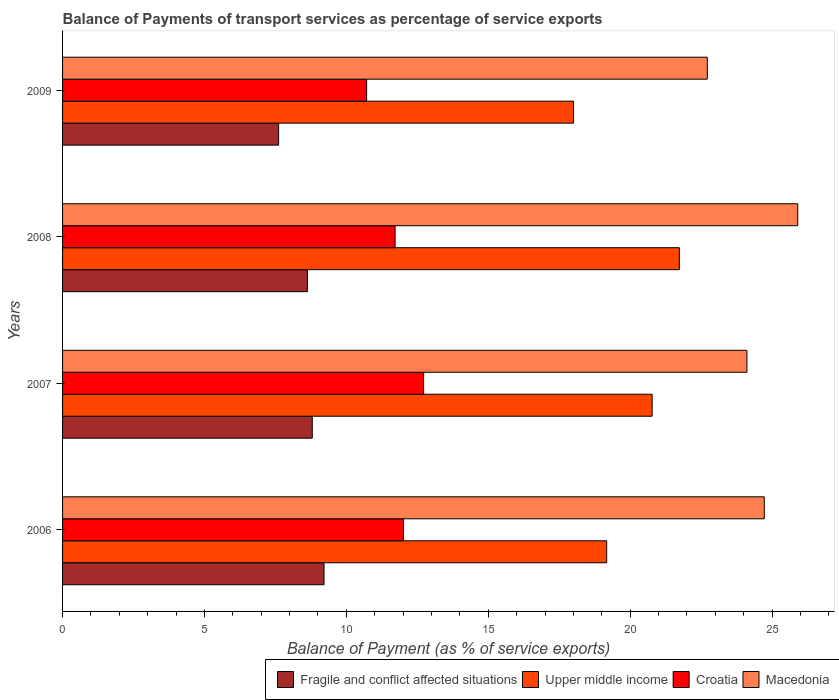How many different coloured bars are there?
Keep it short and to the point. 4. How many groups of bars are there?
Your answer should be very brief. 4. Are the number of bars per tick equal to the number of legend labels?
Make the answer very short. Yes. Are the number of bars on each tick of the Y-axis equal?
Your response must be concise. Yes. What is the label of the 1st group of bars from the top?
Give a very brief answer. 2009. In how many cases, is the number of bars for a given year not equal to the number of legend labels?
Make the answer very short. 0. What is the balance of payments of transport services in Croatia in 2009?
Provide a succinct answer. 10.71. Across all years, what is the maximum balance of payments of transport services in Upper middle income?
Your answer should be very brief. 21.73. Across all years, what is the minimum balance of payments of transport services in Croatia?
Your answer should be compact. 10.71. What is the total balance of payments of transport services in Upper middle income in the graph?
Keep it short and to the point. 79.69. What is the difference between the balance of payments of transport services in Upper middle income in 2007 and that in 2009?
Your answer should be compact. 2.77. What is the difference between the balance of payments of transport services in Macedonia in 2009 and the balance of payments of transport services in Croatia in 2007?
Give a very brief answer. 10. What is the average balance of payments of transport services in Croatia per year?
Your response must be concise. 11.79. In the year 2008, what is the difference between the balance of payments of transport services in Macedonia and balance of payments of transport services in Upper middle income?
Provide a short and direct response. 4.17. What is the ratio of the balance of payments of transport services in Macedonia in 2006 to that in 2007?
Ensure brevity in your answer.  1.03. Is the difference between the balance of payments of transport services in Macedonia in 2007 and 2009 greater than the difference between the balance of payments of transport services in Upper middle income in 2007 and 2009?
Offer a very short reply. No. What is the difference between the highest and the second highest balance of payments of transport services in Fragile and conflict affected situations?
Provide a short and direct response. 0.41. What is the difference between the highest and the lowest balance of payments of transport services in Macedonia?
Ensure brevity in your answer.  3.19. In how many years, is the balance of payments of transport services in Upper middle income greater than the average balance of payments of transport services in Upper middle income taken over all years?
Ensure brevity in your answer.  2. Is it the case that in every year, the sum of the balance of payments of transport services in Fragile and conflict affected situations and balance of payments of transport services in Upper middle income is greater than the sum of balance of payments of transport services in Croatia and balance of payments of transport services in Macedonia?
Offer a very short reply. No. What does the 1st bar from the top in 2009 represents?
Your answer should be very brief. Macedonia. What does the 1st bar from the bottom in 2007 represents?
Ensure brevity in your answer.  Fragile and conflict affected situations. Is it the case that in every year, the sum of the balance of payments of transport services in Macedonia and balance of payments of transport services in Upper middle income is greater than the balance of payments of transport services in Fragile and conflict affected situations?
Your response must be concise. Yes. Are all the bars in the graph horizontal?
Keep it short and to the point. Yes. Are the values on the major ticks of X-axis written in scientific E-notation?
Your answer should be very brief. No. Does the graph contain any zero values?
Offer a very short reply. No. Where does the legend appear in the graph?
Provide a succinct answer. Bottom right. What is the title of the graph?
Your answer should be compact. Balance of Payments of transport services as percentage of service exports. Does "Germany" appear as one of the legend labels in the graph?
Make the answer very short. No. What is the label or title of the X-axis?
Ensure brevity in your answer.  Balance of Payment (as % of service exports). What is the label or title of the Y-axis?
Your response must be concise. Years. What is the Balance of Payment (as % of service exports) of Fragile and conflict affected situations in 2006?
Ensure brevity in your answer.  9.21. What is the Balance of Payment (as % of service exports) in Upper middle income in 2006?
Your answer should be compact. 19.17. What is the Balance of Payment (as % of service exports) in Croatia in 2006?
Make the answer very short. 12.01. What is the Balance of Payment (as % of service exports) of Macedonia in 2006?
Ensure brevity in your answer.  24.73. What is the Balance of Payment (as % of service exports) of Fragile and conflict affected situations in 2007?
Your response must be concise. 8.8. What is the Balance of Payment (as % of service exports) of Upper middle income in 2007?
Make the answer very short. 20.77. What is the Balance of Payment (as % of service exports) of Croatia in 2007?
Provide a short and direct response. 12.72. What is the Balance of Payment (as % of service exports) in Macedonia in 2007?
Offer a very short reply. 24.12. What is the Balance of Payment (as % of service exports) of Fragile and conflict affected situations in 2008?
Your answer should be compact. 8.63. What is the Balance of Payment (as % of service exports) in Upper middle income in 2008?
Your answer should be compact. 21.73. What is the Balance of Payment (as % of service exports) of Croatia in 2008?
Make the answer very short. 11.72. What is the Balance of Payment (as % of service exports) of Macedonia in 2008?
Keep it short and to the point. 25.91. What is the Balance of Payment (as % of service exports) of Fragile and conflict affected situations in 2009?
Offer a very short reply. 7.61. What is the Balance of Payment (as % of service exports) in Upper middle income in 2009?
Your response must be concise. 18.01. What is the Balance of Payment (as % of service exports) in Croatia in 2009?
Offer a terse response. 10.71. What is the Balance of Payment (as % of service exports) in Macedonia in 2009?
Ensure brevity in your answer.  22.72. Across all years, what is the maximum Balance of Payment (as % of service exports) of Fragile and conflict affected situations?
Your answer should be very brief. 9.21. Across all years, what is the maximum Balance of Payment (as % of service exports) in Upper middle income?
Offer a terse response. 21.73. Across all years, what is the maximum Balance of Payment (as % of service exports) in Croatia?
Provide a succinct answer. 12.72. Across all years, what is the maximum Balance of Payment (as % of service exports) of Macedonia?
Your answer should be very brief. 25.91. Across all years, what is the minimum Balance of Payment (as % of service exports) in Fragile and conflict affected situations?
Offer a terse response. 7.61. Across all years, what is the minimum Balance of Payment (as % of service exports) in Upper middle income?
Keep it short and to the point. 18.01. Across all years, what is the minimum Balance of Payment (as % of service exports) of Croatia?
Make the answer very short. 10.71. Across all years, what is the minimum Balance of Payment (as % of service exports) of Macedonia?
Make the answer very short. 22.72. What is the total Balance of Payment (as % of service exports) in Fragile and conflict affected situations in the graph?
Your answer should be compact. 34.25. What is the total Balance of Payment (as % of service exports) of Upper middle income in the graph?
Offer a very short reply. 79.69. What is the total Balance of Payment (as % of service exports) of Croatia in the graph?
Your response must be concise. 47.17. What is the total Balance of Payment (as % of service exports) of Macedonia in the graph?
Keep it short and to the point. 97.47. What is the difference between the Balance of Payment (as % of service exports) in Fragile and conflict affected situations in 2006 and that in 2007?
Give a very brief answer. 0.41. What is the difference between the Balance of Payment (as % of service exports) of Upper middle income in 2006 and that in 2007?
Your answer should be very brief. -1.6. What is the difference between the Balance of Payment (as % of service exports) in Croatia in 2006 and that in 2007?
Provide a short and direct response. -0.71. What is the difference between the Balance of Payment (as % of service exports) of Macedonia in 2006 and that in 2007?
Your answer should be compact. 0.61. What is the difference between the Balance of Payment (as % of service exports) in Fragile and conflict affected situations in 2006 and that in 2008?
Your answer should be compact. 0.59. What is the difference between the Balance of Payment (as % of service exports) of Upper middle income in 2006 and that in 2008?
Give a very brief answer. -2.56. What is the difference between the Balance of Payment (as % of service exports) of Croatia in 2006 and that in 2008?
Give a very brief answer. 0.3. What is the difference between the Balance of Payment (as % of service exports) of Macedonia in 2006 and that in 2008?
Your answer should be compact. -1.18. What is the difference between the Balance of Payment (as % of service exports) of Fragile and conflict affected situations in 2006 and that in 2009?
Provide a succinct answer. 1.6. What is the difference between the Balance of Payment (as % of service exports) in Upper middle income in 2006 and that in 2009?
Offer a terse response. 1.17. What is the difference between the Balance of Payment (as % of service exports) in Croatia in 2006 and that in 2009?
Provide a short and direct response. 1.3. What is the difference between the Balance of Payment (as % of service exports) of Macedonia in 2006 and that in 2009?
Your response must be concise. 2.01. What is the difference between the Balance of Payment (as % of service exports) of Fragile and conflict affected situations in 2007 and that in 2008?
Offer a terse response. 0.17. What is the difference between the Balance of Payment (as % of service exports) in Upper middle income in 2007 and that in 2008?
Make the answer very short. -0.96. What is the difference between the Balance of Payment (as % of service exports) in Croatia in 2007 and that in 2008?
Your response must be concise. 1.01. What is the difference between the Balance of Payment (as % of service exports) in Macedonia in 2007 and that in 2008?
Give a very brief answer. -1.79. What is the difference between the Balance of Payment (as % of service exports) of Fragile and conflict affected situations in 2007 and that in 2009?
Offer a very short reply. 1.19. What is the difference between the Balance of Payment (as % of service exports) of Upper middle income in 2007 and that in 2009?
Provide a short and direct response. 2.77. What is the difference between the Balance of Payment (as % of service exports) in Croatia in 2007 and that in 2009?
Your response must be concise. 2.01. What is the difference between the Balance of Payment (as % of service exports) of Macedonia in 2007 and that in 2009?
Keep it short and to the point. 1.4. What is the difference between the Balance of Payment (as % of service exports) in Fragile and conflict affected situations in 2008 and that in 2009?
Offer a terse response. 1.01. What is the difference between the Balance of Payment (as % of service exports) of Upper middle income in 2008 and that in 2009?
Offer a terse response. 3.73. What is the difference between the Balance of Payment (as % of service exports) of Macedonia in 2008 and that in 2009?
Make the answer very short. 3.19. What is the difference between the Balance of Payment (as % of service exports) in Fragile and conflict affected situations in 2006 and the Balance of Payment (as % of service exports) in Upper middle income in 2007?
Provide a short and direct response. -11.56. What is the difference between the Balance of Payment (as % of service exports) in Fragile and conflict affected situations in 2006 and the Balance of Payment (as % of service exports) in Croatia in 2007?
Keep it short and to the point. -3.51. What is the difference between the Balance of Payment (as % of service exports) of Fragile and conflict affected situations in 2006 and the Balance of Payment (as % of service exports) of Macedonia in 2007?
Provide a succinct answer. -14.9. What is the difference between the Balance of Payment (as % of service exports) of Upper middle income in 2006 and the Balance of Payment (as % of service exports) of Croatia in 2007?
Your answer should be very brief. 6.45. What is the difference between the Balance of Payment (as % of service exports) of Upper middle income in 2006 and the Balance of Payment (as % of service exports) of Macedonia in 2007?
Your answer should be compact. -4.94. What is the difference between the Balance of Payment (as % of service exports) of Croatia in 2006 and the Balance of Payment (as % of service exports) of Macedonia in 2007?
Your response must be concise. -12.1. What is the difference between the Balance of Payment (as % of service exports) of Fragile and conflict affected situations in 2006 and the Balance of Payment (as % of service exports) of Upper middle income in 2008?
Your answer should be compact. -12.52. What is the difference between the Balance of Payment (as % of service exports) in Fragile and conflict affected situations in 2006 and the Balance of Payment (as % of service exports) in Croatia in 2008?
Your response must be concise. -2.5. What is the difference between the Balance of Payment (as % of service exports) of Fragile and conflict affected situations in 2006 and the Balance of Payment (as % of service exports) of Macedonia in 2008?
Provide a short and direct response. -16.69. What is the difference between the Balance of Payment (as % of service exports) in Upper middle income in 2006 and the Balance of Payment (as % of service exports) in Croatia in 2008?
Ensure brevity in your answer.  7.46. What is the difference between the Balance of Payment (as % of service exports) of Upper middle income in 2006 and the Balance of Payment (as % of service exports) of Macedonia in 2008?
Make the answer very short. -6.73. What is the difference between the Balance of Payment (as % of service exports) in Croatia in 2006 and the Balance of Payment (as % of service exports) in Macedonia in 2008?
Make the answer very short. -13.89. What is the difference between the Balance of Payment (as % of service exports) of Fragile and conflict affected situations in 2006 and the Balance of Payment (as % of service exports) of Upper middle income in 2009?
Offer a terse response. -8.79. What is the difference between the Balance of Payment (as % of service exports) of Fragile and conflict affected situations in 2006 and the Balance of Payment (as % of service exports) of Croatia in 2009?
Offer a terse response. -1.5. What is the difference between the Balance of Payment (as % of service exports) in Fragile and conflict affected situations in 2006 and the Balance of Payment (as % of service exports) in Macedonia in 2009?
Keep it short and to the point. -13.51. What is the difference between the Balance of Payment (as % of service exports) of Upper middle income in 2006 and the Balance of Payment (as % of service exports) of Croatia in 2009?
Give a very brief answer. 8.46. What is the difference between the Balance of Payment (as % of service exports) of Upper middle income in 2006 and the Balance of Payment (as % of service exports) of Macedonia in 2009?
Offer a very short reply. -3.55. What is the difference between the Balance of Payment (as % of service exports) of Croatia in 2006 and the Balance of Payment (as % of service exports) of Macedonia in 2009?
Offer a very short reply. -10.71. What is the difference between the Balance of Payment (as % of service exports) of Fragile and conflict affected situations in 2007 and the Balance of Payment (as % of service exports) of Upper middle income in 2008?
Make the answer very short. -12.94. What is the difference between the Balance of Payment (as % of service exports) in Fragile and conflict affected situations in 2007 and the Balance of Payment (as % of service exports) in Croatia in 2008?
Offer a very short reply. -2.92. What is the difference between the Balance of Payment (as % of service exports) in Fragile and conflict affected situations in 2007 and the Balance of Payment (as % of service exports) in Macedonia in 2008?
Your answer should be very brief. -17.11. What is the difference between the Balance of Payment (as % of service exports) of Upper middle income in 2007 and the Balance of Payment (as % of service exports) of Croatia in 2008?
Your answer should be compact. 9.06. What is the difference between the Balance of Payment (as % of service exports) of Upper middle income in 2007 and the Balance of Payment (as % of service exports) of Macedonia in 2008?
Your answer should be very brief. -5.13. What is the difference between the Balance of Payment (as % of service exports) of Croatia in 2007 and the Balance of Payment (as % of service exports) of Macedonia in 2008?
Give a very brief answer. -13.18. What is the difference between the Balance of Payment (as % of service exports) of Fragile and conflict affected situations in 2007 and the Balance of Payment (as % of service exports) of Upper middle income in 2009?
Offer a very short reply. -9.21. What is the difference between the Balance of Payment (as % of service exports) of Fragile and conflict affected situations in 2007 and the Balance of Payment (as % of service exports) of Croatia in 2009?
Give a very brief answer. -1.92. What is the difference between the Balance of Payment (as % of service exports) in Fragile and conflict affected situations in 2007 and the Balance of Payment (as % of service exports) in Macedonia in 2009?
Your answer should be compact. -13.92. What is the difference between the Balance of Payment (as % of service exports) of Upper middle income in 2007 and the Balance of Payment (as % of service exports) of Croatia in 2009?
Make the answer very short. 10.06. What is the difference between the Balance of Payment (as % of service exports) in Upper middle income in 2007 and the Balance of Payment (as % of service exports) in Macedonia in 2009?
Your answer should be compact. -1.95. What is the difference between the Balance of Payment (as % of service exports) in Croatia in 2007 and the Balance of Payment (as % of service exports) in Macedonia in 2009?
Keep it short and to the point. -10. What is the difference between the Balance of Payment (as % of service exports) in Fragile and conflict affected situations in 2008 and the Balance of Payment (as % of service exports) in Upper middle income in 2009?
Keep it short and to the point. -9.38. What is the difference between the Balance of Payment (as % of service exports) of Fragile and conflict affected situations in 2008 and the Balance of Payment (as % of service exports) of Croatia in 2009?
Your response must be concise. -2.09. What is the difference between the Balance of Payment (as % of service exports) in Fragile and conflict affected situations in 2008 and the Balance of Payment (as % of service exports) in Macedonia in 2009?
Your answer should be compact. -14.09. What is the difference between the Balance of Payment (as % of service exports) in Upper middle income in 2008 and the Balance of Payment (as % of service exports) in Croatia in 2009?
Give a very brief answer. 11.02. What is the difference between the Balance of Payment (as % of service exports) in Upper middle income in 2008 and the Balance of Payment (as % of service exports) in Macedonia in 2009?
Provide a short and direct response. -0.99. What is the difference between the Balance of Payment (as % of service exports) in Croatia in 2008 and the Balance of Payment (as % of service exports) in Macedonia in 2009?
Provide a succinct answer. -11. What is the average Balance of Payment (as % of service exports) in Fragile and conflict affected situations per year?
Your response must be concise. 8.56. What is the average Balance of Payment (as % of service exports) in Upper middle income per year?
Offer a terse response. 19.92. What is the average Balance of Payment (as % of service exports) in Croatia per year?
Make the answer very short. 11.79. What is the average Balance of Payment (as % of service exports) in Macedonia per year?
Your answer should be compact. 24.37. In the year 2006, what is the difference between the Balance of Payment (as % of service exports) in Fragile and conflict affected situations and Balance of Payment (as % of service exports) in Upper middle income?
Make the answer very short. -9.96. In the year 2006, what is the difference between the Balance of Payment (as % of service exports) in Fragile and conflict affected situations and Balance of Payment (as % of service exports) in Croatia?
Provide a succinct answer. -2.8. In the year 2006, what is the difference between the Balance of Payment (as % of service exports) of Fragile and conflict affected situations and Balance of Payment (as % of service exports) of Macedonia?
Offer a very short reply. -15.51. In the year 2006, what is the difference between the Balance of Payment (as % of service exports) in Upper middle income and Balance of Payment (as % of service exports) in Croatia?
Give a very brief answer. 7.16. In the year 2006, what is the difference between the Balance of Payment (as % of service exports) of Upper middle income and Balance of Payment (as % of service exports) of Macedonia?
Your answer should be compact. -5.55. In the year 2006, what is the difference between the Balance of Payment (as % of service exports) of Croatia and Balance of Payment (as % of service exports) of Macedonia?
Provide a succinct answer. -12.71. In the year 2007, what is the difference between the Balance of Payment (as % of service exports) of Fragile and conflict affected situations and Balance of Payment (as % of service exports) of Upper middle income?
Your answer should be very brief. -11.98. In the year 2007, what is the difference between the Balance of Payment (as % of service exports) in Fragile and conflict affected situations and Balance of Payment (as % of service exports) in Croatia?
Provide a succinct answer. -3.92. In the year 2007, what is the difference between the Balance of Payment (as % of service exports) of Fragile and conflict affected situations and Balance of Payment (as % of service exports) of Macedonia?
Your response must be concise. -15.32. In the year 2007, what is the difference between the Balance of Payment (as % of service exports) of Upper middle income and Balance of Payment (as % of service exports) of Croatia?
Your response must be concise. 8.05. In the year 2007, what is the difference between the Balance of Payment (as % of service exports) in Upper middle income and Balance of Payment (as % of service exports) in Macedonia?
Offer a very short reply. -3.34. In the year 2007, what is the difference between the Balance of Payment (as % of service exports) in Croatia and Balance of Payment (as % of service exports) in Macedonia?
Give a very brief answer. -11.39. In the year 2008, what is the difference between the Balance of Payment (as % of service exports) of Fragile and conflict affected situations and Balance of Payment (as % of service exports) of Upper middle income?
Offer a very short reply. -13.11. In the year 2008, what is the difference between the Balance of Payment (as % of service exports) in Fragile and conflict affected situations and Balance of Payment (as % of service exports) in Croatia?
Your answer should be very brief. -3.09. In the year 2008, what is the difference between the Balance of Payment (as % of service exports) of Fragile and conflict affected situations and Balance of Payment (as % of service exports) of Macedonia?
Give a very brief answer. -17.28. In the year 2008, what is the difference between the Balance of Payment (as % of service exports) of Upper middle income and Balance of Payment (as % of service exports) of Croatia?
Give a very brief answer. 10.02. In the year 2008, what is the difference between the Balance of Payment (as % of service exports) in Upper middle income and Balance of Payment (as % of service exports) in Macedonia?
Your answer should be very brief. -4.17. In the year 2008, what is the difference between the Balance of Payment (as % of service exports) of Croatia and Balance of Payment (as % of service exports) of Macedonia?
Keep it short and to the point. -14.19. In the year 2009, what is the difference between the Balance of Payment (as % of service exports) of Fragile and conflict affected situations and Balance of Payment (as % of service exports) of Upper middle income?
Your answer should be compact. -10.39. In the year 2009, what is the difference between the Balance of Payment (as % of service exports) in Fragile and conflict affected situations and Balance of Payment (as % of service exports) in Croatia?
Make the answer very short. -3.1. In the year 2009, what is the difference between the Balance of Payment (as % of service exports) of Fragile and conflict affected situations and Balance of Payment (as % of service exports) of Macedonia?
Make the answer very short. -15.11. In the year 2009, what is the difference between the Balance of Payment (as % of service exports) in Upper middle income and Balance of Payment (as % of service exports) in Croatia?
Provide a short and direct response. 7.29. In the year 2009, what is the difference between the Balance of Payment (as % of service exports) in Upper middle income and Balance of Payment (as % of service exports) in Macedonia?
Offer a very short reply. -4.71. In the year 2009, what is the difference between the Balance of Payment (as % of service exports) in Croatia and Balance of Payment (as % of service exports) in Macedonia?
Offer a terse response. -12.01. What is the ratio of the Balance of Payment (as % of service exports) of Fragile and conflict affected situations in 2006 to that in 2007?
Your response must be concise. 1.05. What is the ratio of the Balance of Payment (as % of service exports) of Upper middle income in 2006 to that in 2007?
Give a very brief answer. 0.92. What is the ratio of the Balance of Payment (as % of service exports) of Croatia in 2006 to that in 2007?
Ensure brevity in your answer.  0.94. What is the ratio of the Balance of Payment (as % of service exports) in Macedonia in 2006 to that in 2007?
Your answer should be compact. 1.03. What is the ratio of the Balance of Payment (as % of service exports) in Fragile and conflict affected situations in 2006 to that in 2008?
Your response must be concise. 1.07. What is the ratio of the Balance of Payment (as % of service exports) in Upper middle income in 2006 to that in 2008?
Give a very brief answer. 0.88. What is the ratio of the Balance of Payment (as % of service exports) in Croatia in 2006 to that in 2008?
Your response must be concise. 1.03. What is the ratio of the Balance of Payment (as % of service exports) of Macedonia in 2006 to that in 2008?
Your answer should be very brief. 0.95. What is the ratio of the Balance of Payment (as % of service exports) of Fragile and conflict affected situations in 2006 to that in 2009?
Your response must be concise. 1.21. What is the ratio of the Balance of Payment (as % of service exports) in Upper middle income in 2006 to that in 2009?
Provide a succinct answer. 1.06. What is the ratio of the Balance of Payment (as % of service exports) in Croatia in 2006 to that in 2009?
Ensure brevity in your answer.  1.12. What is the ratio of the Balance of Payment (as % of service exports) of Macedonia in 2006 to that in 2009?
Your answer should be very brief. 1.09. What is the ratio of the Balance of Payment (as % of service exports) of Fragile and conflict affected situations in 2007 to that in 2008?
Make the answer very short. 1.02. What is the ratio of the Balance of Payment (as % of service exports) of Upper middle income in 2007 to that in 2008?
Offer a very short reply. 0.96. What is the ratio of the Balance of Payment (as % of service exports) in Croatia in 2007 to that in 2008?
Offer a terse response. 1.09. What is the ratio of the Balance of Payment (as % of service exports) in Macedonia in 2007 to that in 2008?
Ensure brevity in your answer.  0.93. What is the ratio of the Balance of Payment (as % of service exports) in Fragile and conflict affected situations in 2007 to that in 2009?
Offer a very short reply. 1.16. What is the ratio of the Balance of Payment (as % of service exports) of Upper middle income in 2007 to that in 2009?
Offer a very short reply. 1.15. What is the ratio of the Balance of Payment (as % of service exports) in Croatia in 2007 to that in 2009?
Keep it short and to the point. 1.19. What is the ratio of the Balance of Payment (as % of service exports) in Macedonia in 2007 to that in 2009?
Ensure brevity in your answer.  1.06. What is the ratio of the Balance of Payment (as % of service exports) in Fragile and conflict affected situations in 2008 to that in 2009?
Make the answer very short. 1.13. What is the ratio of the Balance of Payment (as % of service exports) of Upper middle income in 2008 to that in 2009?
Provide a short and direct response. 1.21. What is the ratio of the Balance of Payment (as % of service exports) in Croatia in 2008 to that in 2009?
Offer a very short reply. 1.09. What is the ratio of the Balance of Payment (as % of service exports) in Macedonia in 2008 to that in 2009?
Your answer should be very brief. 1.14. What is the difference between the highest and the second highest Balance of Payment (as % of service exports) of Fragile and conflict affected situations?
Ensure brevity in your answer.  0.41. What is the difference between the highest and the second highest Balance of Payment (as % of service exports) in Upper middle income?
Keep it short and to the point. 0.96. What is the difference between the highest and the second highest Balance of Payment (as % of service exports) of Croatia?
Provide a short and direct response. 0.71. What is the difference between the highest and the second highest Balance of Payment (as % of service exports) of Macedonia?
Offer a very short reply. 1.18. What is the difference between the highest and the lowest Balance of Payment (as % of service exports) of Fragile and conflict affected situations?
Ensure brevity in your answer.  1.6. What is the difference between the highest and the lowest Balance of Payment (as % of service exports) in Upper middle income?
Ensure brevity in your answer.  3.73. What is the difference between the highest and the lowest Balance of Payment (as % of service exports) in Croatia?
Offer a very short reply. 2.01. What is the difference between the highest and the lowest Balance of Payment (as % of service exports) in Macedonia?
Provide a short and direct response. 3.19. 